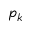Convert formula to latex. <formula><loc_0><loc_0><loc_500><loc_500>p _ { k }</formula> 